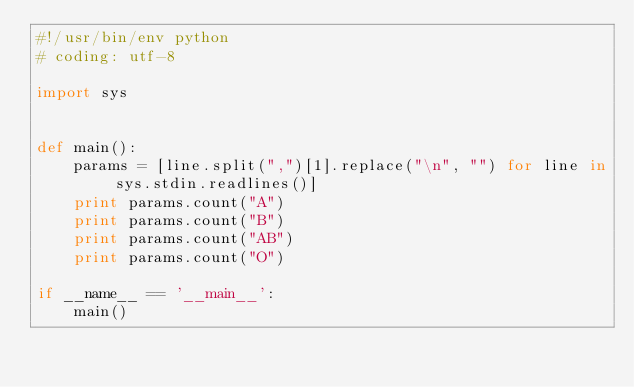Convert code to text. <code><loc_0><loc_0><loc_500><loc_500><_Python_>#!/usr/bin/env python
# coding: utf-8

import sys


def main():
    params = [line.split(",")[1].replace("\n", "") for line in sys.stdin.readlines()]
    print params.count("A")
    print params.count("B")
    print params.count("AB")
    print params.count("O")

if __name__ == '__main__':
    main()</code> 